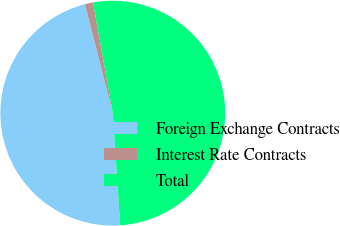Convert chart to OTSL. <chart><loc_0><loc_0><loc_500><loc_500><pie_chart><fcel>Foreign Exchange Contracts<fcel>Interest Rate Contracts<fcel>Total<nl><fcel>47.05%<fcel>1.18%<fcel>51.76%<nl></chart> 